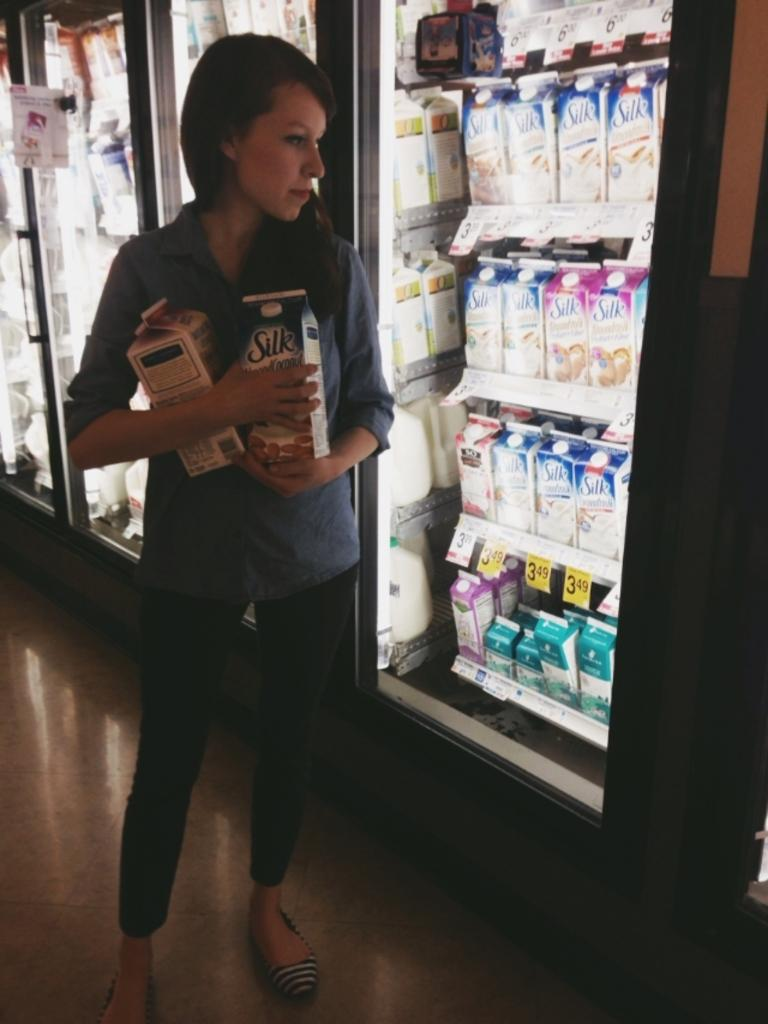Provide a one-sentence caption for the provided image. The half-gallons of Silk were priced at $3.49 and the shopper had selected two. 